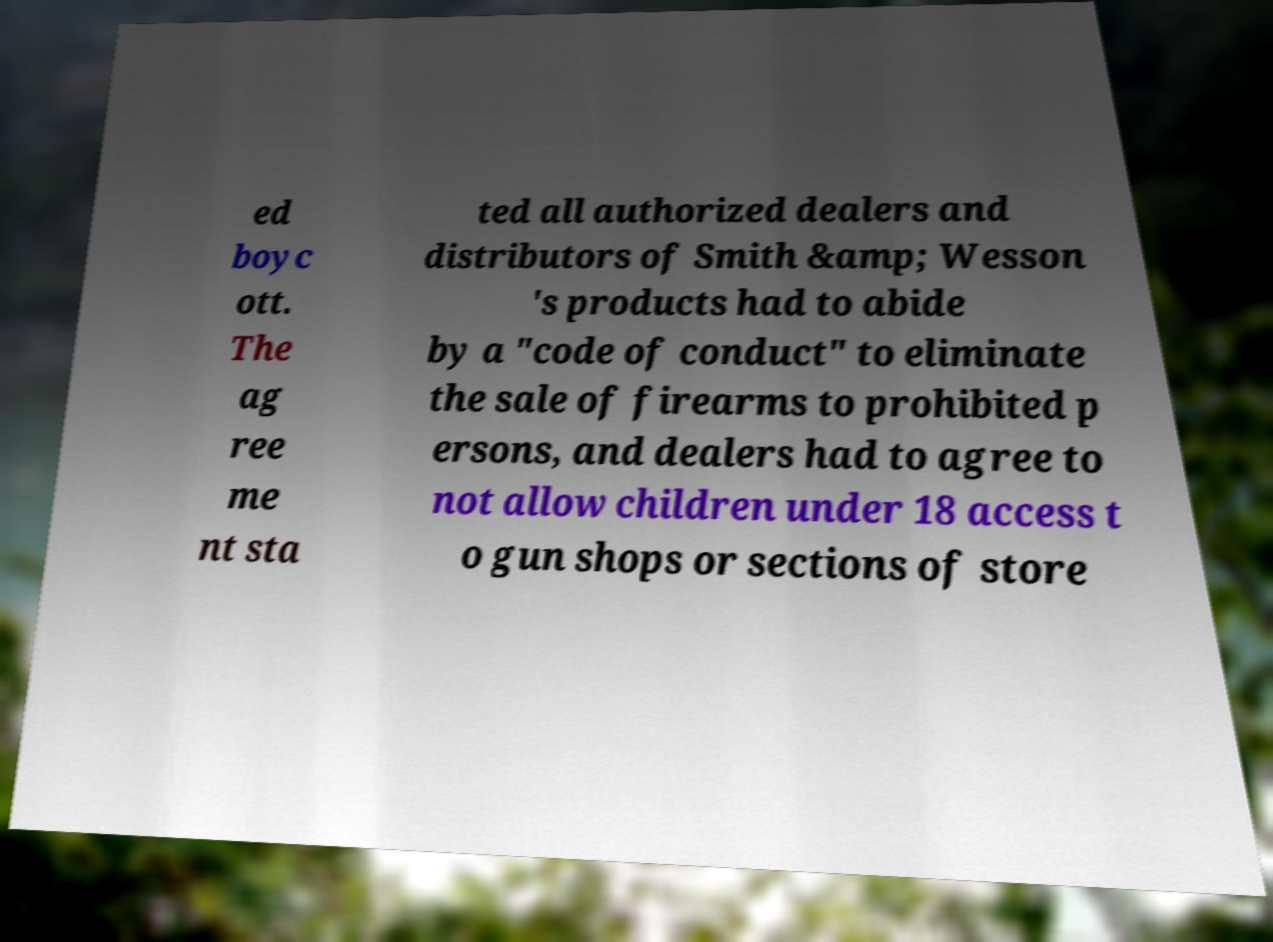There's text embedded in this image that I need extracted. Can you transcribe it verbatim? ed boyc ott. The ag ree me nt sta ted all authorized dealers and distributors of Smith &amp; Wesson 's products had to abide by a "code of conduct" to eliminate the sale of firearms to prohibited p ersons, and dealers had to agree to not allow children under 18 access t o gun shops or sections of store 